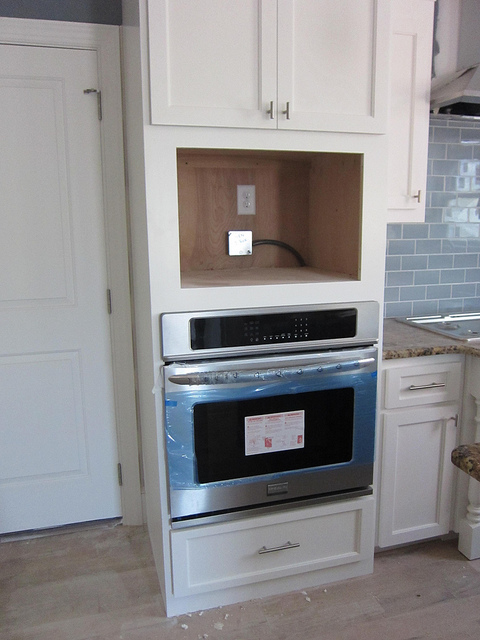<image>What kind of ovens are those? I don't know what kind of ovens are those. They can be conventional, modern, convection, digital or built in. How many empty shelves are pictured? I am not sure, but it can be 1 or 2 empty shelves. What brand is the stove? I don't know what the brand of the stove is. It could be LG, Emerson, Kenmore, Viking, Kitchenaid or General Electric. How many empty shelves are pictured? I am not sure how many empty shelves are pictured in the image. It can be seen one or two empty shelves. What brand is the stove? I don't know what brand the stove is. It can be LG, Emerson, Kenmore, Viking, KitchenAid, General Electric, or unknown. What kind of ovens are those? I don't know what kind of ovens those are. It can be seen 'conventional', 'modern', 'convection', 'new', 'built in' or 'digital'. 